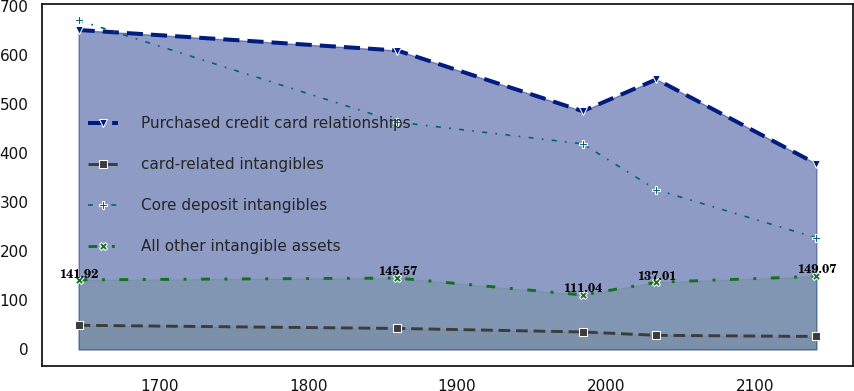Convert chart to OTSL. <chart><loc_0><loc_0><loc_500><loc_500><line_chart><ecel><fcel>Purchased credit card relationships<fcel>card-related intangibles<fcel>Core deposit intangibles<fcel>All other intangible assets<nl><fcel>1645.65<fcel>651.52<fcel>49.21<fcel>671.12<fcel>141.92<nl><fcel>1859.93<fcel>609.62<fcel>42.81<fcel>463.62<fcel>145.57<nl><fcel>1984.38<fcel>485.95<fcel>35.62<fcel>419.28<fcel>111.04<nl><fcel>2033.96<fcel>550.86<fcel>28.73<fcel>325.61<fcel>137.01<nl><fcel>2141.44<fcel>378.45<fcel>26.45<fcel>227.77<fcel>149.07<nl></chart> 